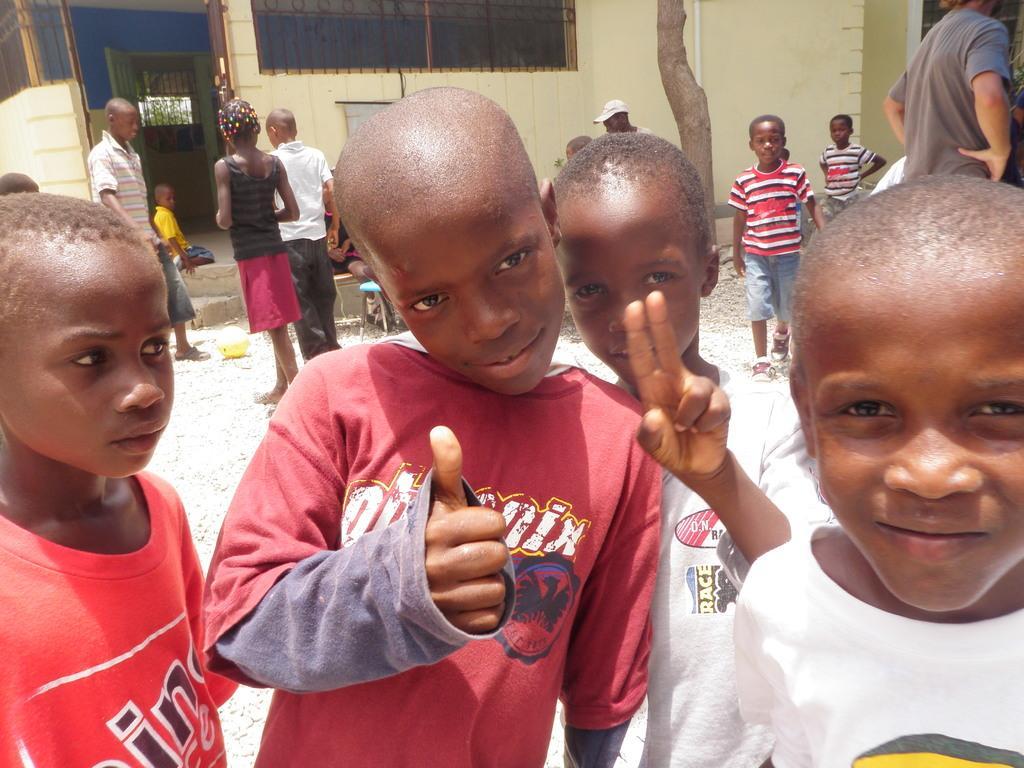Describe this image in one or two sentences. This picture is clicked outside. In the foreground we can see the children wearing t-shirts and standing on the ground. On the right there is a person wearing t-shirt like object and standing. In the center we can see the group of children seems to be standing on the ground. In the background we can see the trunk of a tree and we can see the building and a kid sitting on the ground and we can see the stairs and some other objects. 